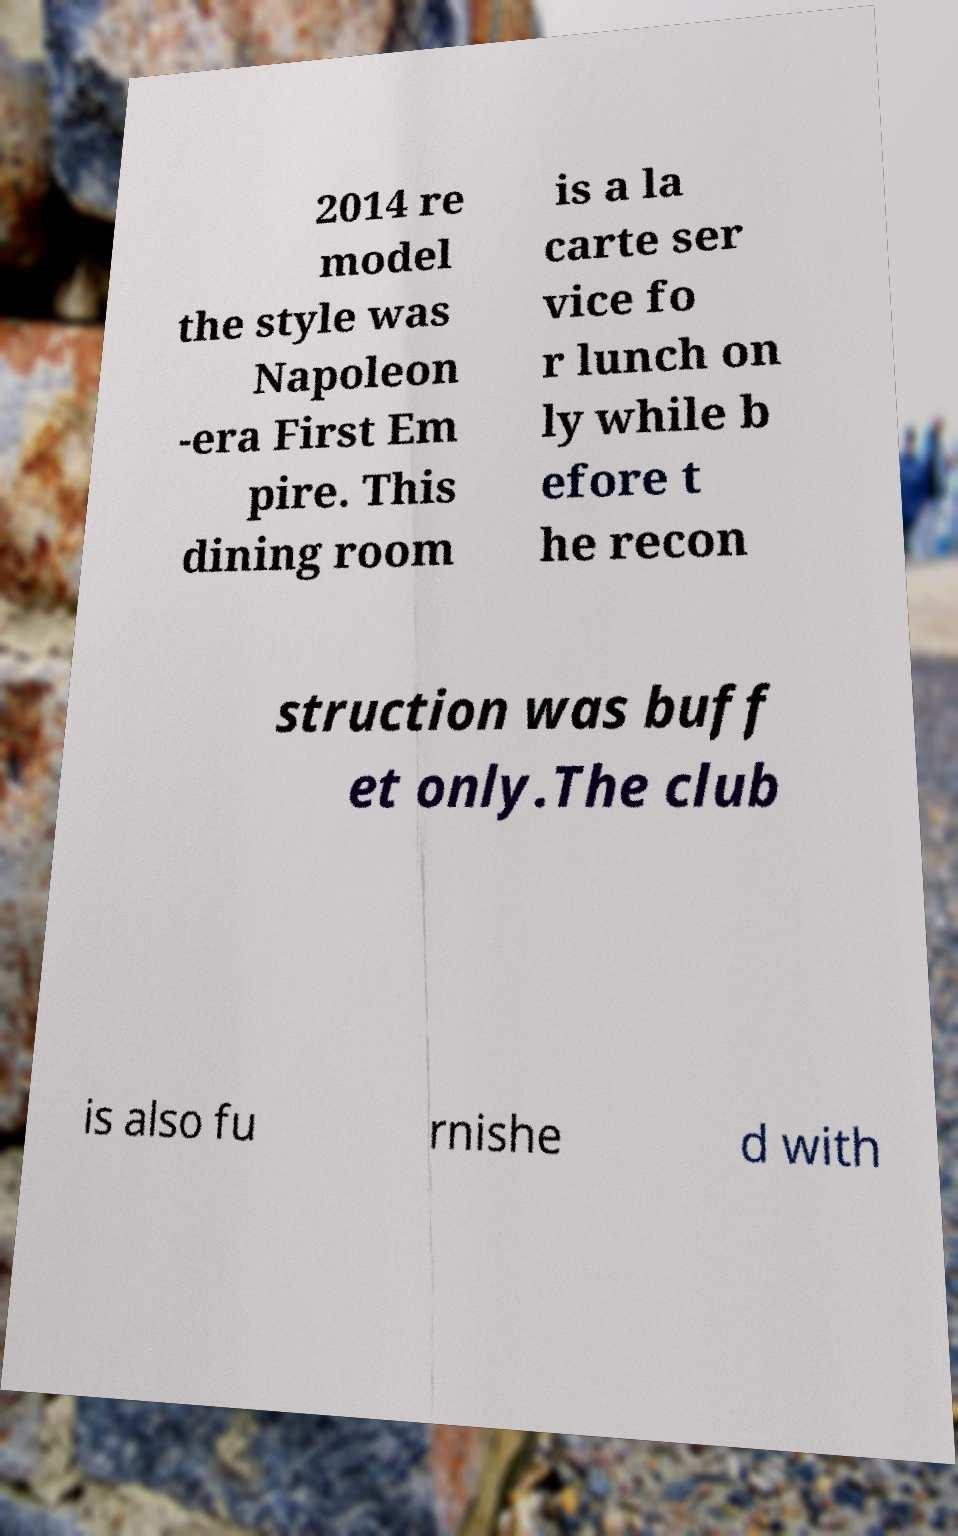Can you read and provide the text displayed in the image?This photo seems to have some interesting text. Can you extract and type it out for me? 2014 re model the style was Napoleon -era First Em pire. This dining room is a la carte ser vice fo r lunch on ly while b efore t he recon struction was buff et only.The club is also fu rnishe d with 